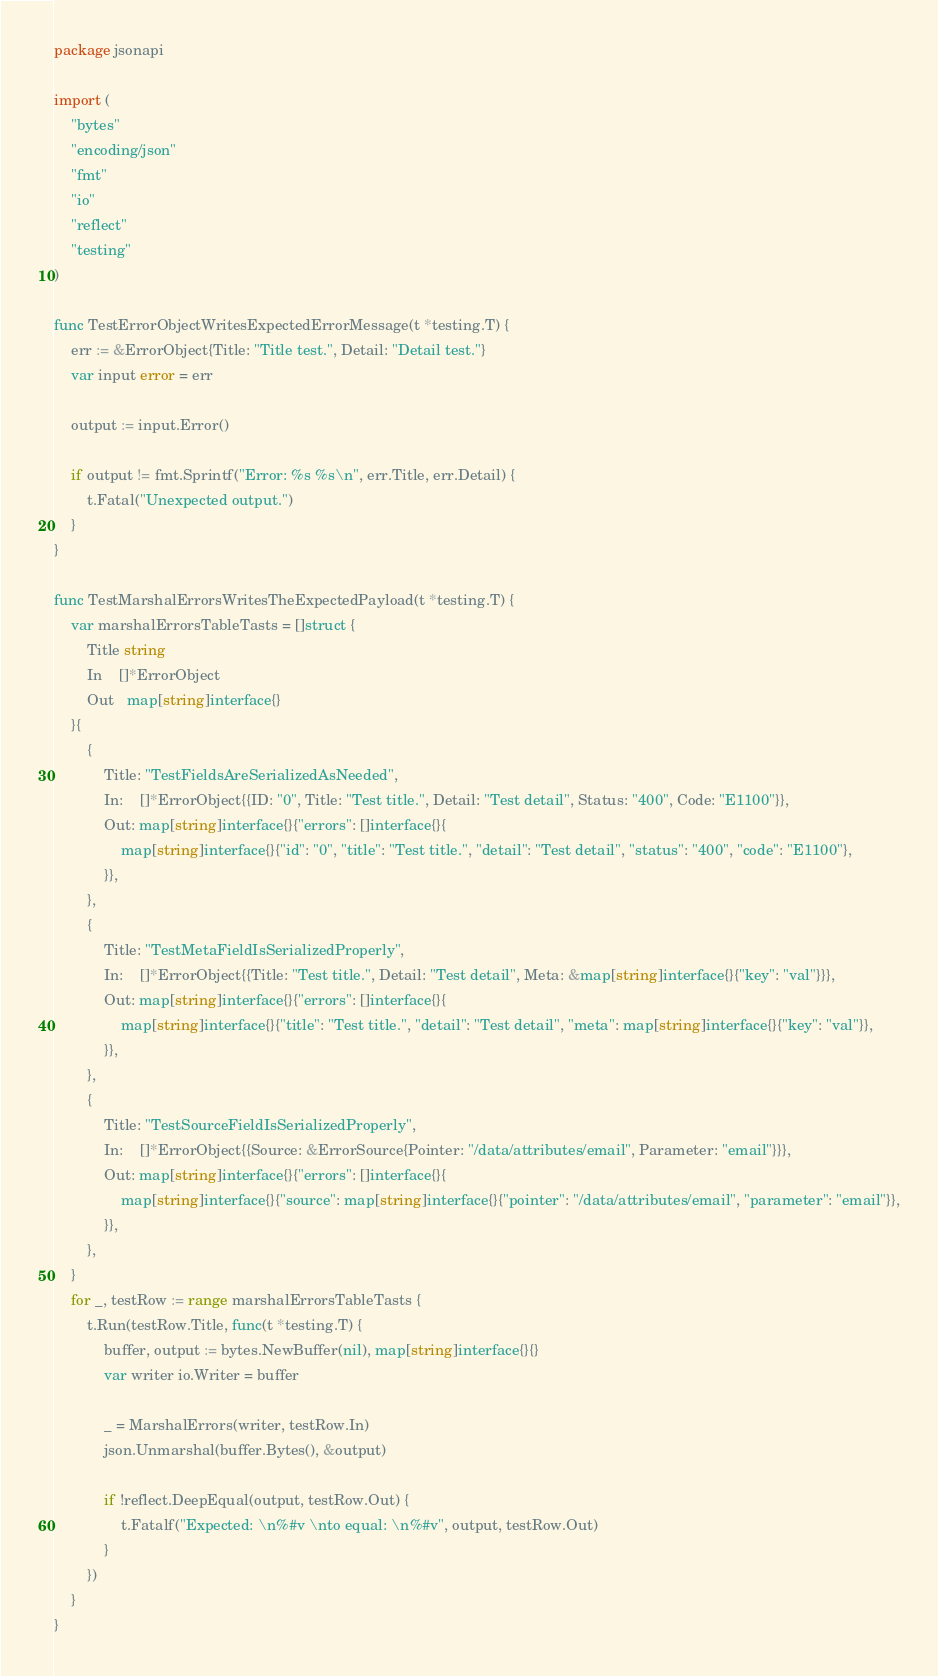Convert code to text. <code><loc_0><loc_0><loc_500><loc_500><_Go_>package jsonapi

import (
	"bytes"
	"encoding/json"
	"fmt"
	"io"
	"reflect"
	"testing"
)

func TestErrorObjectWritesExpectedErrorMessage(t *testing.T) {
	err := &ErrorObject{Title: "Title test.", Detail: "Detail test."}
	var input error = err

	output := input.Error()

	if output != fmt.Sprintf("Error: %s %s\n", err.Title, err.Detail) {
		t.Fatal("Unexpected output.")
	}
}

func TestMarshalErrorsWritesTheExpectedPayload(t *testing.T) {
	var marshalErrorsTableTasts = []struct {
		Title string
		In    []*ErrorObject
		Out   map[string]interface{}
	}{
		{
			Title: "TestFieldsAreSerializedAsNeeded",
			In:    []*ErrorObject{{ID: "0", Title: "Test title.", Detail: "Test detail", Status: "400", Code: "E1100"}},
			Out: map[string]interface{}{"errors": []interface{}{
				map[string]interface{}{"id": "0", "title": "Test title.", "detail": "Test detail", "status": "400", "code": "E1100"},
			}},
		},
		{
			Title: "TestMetaFieldIsSerializedProperly",
			In:    []*ErrorObject{{Title: "Test title.", Detail: "Test detail", Meta: &map[string]interface{}{"key": "val"}}},
			Out: map[string]interface{}{"errors": []interface{}{
				map[string]interface{}{"title": "Test title.", "detail": "Test detail", "meta": map[string]interface{}{"key": "val"}},
			}},
		},
		{
			Title: "TestSourceFieldIsSerializedProperly",
			In:    []*ErrorObject{{Source: &ErrorSource{Pointer: "/data/attributes/email", Parameter: "email"}}},
			Out: map[string]interface{}{"errors": []interface{}{
				map[string]interface{}{"source": map[string]interface{}{"pointer": "/data/attributes/email", "parameter": "email"}},
			}},
		},
	}
	for _, testRow := range marshalErrorsTableTasts {
		t.Run(testRow.Title, func(t *testing.T) {
			buffer, output := bytes.NewBuffer(nil), map[string]interface{}{}
			var writer io.Writer = buffer

			_ = MarshalErrors(writer, testRow.In)
			json.Unmarshal(buffer.Bytes(), &output)

			if !reflect.DeepEqual(output, testRow.Out) {
				t.Fatalf("Expected: \n%#v \nto equal: \n%#v", output, testRow.Out)
			}
		})
	}
}
</code> 